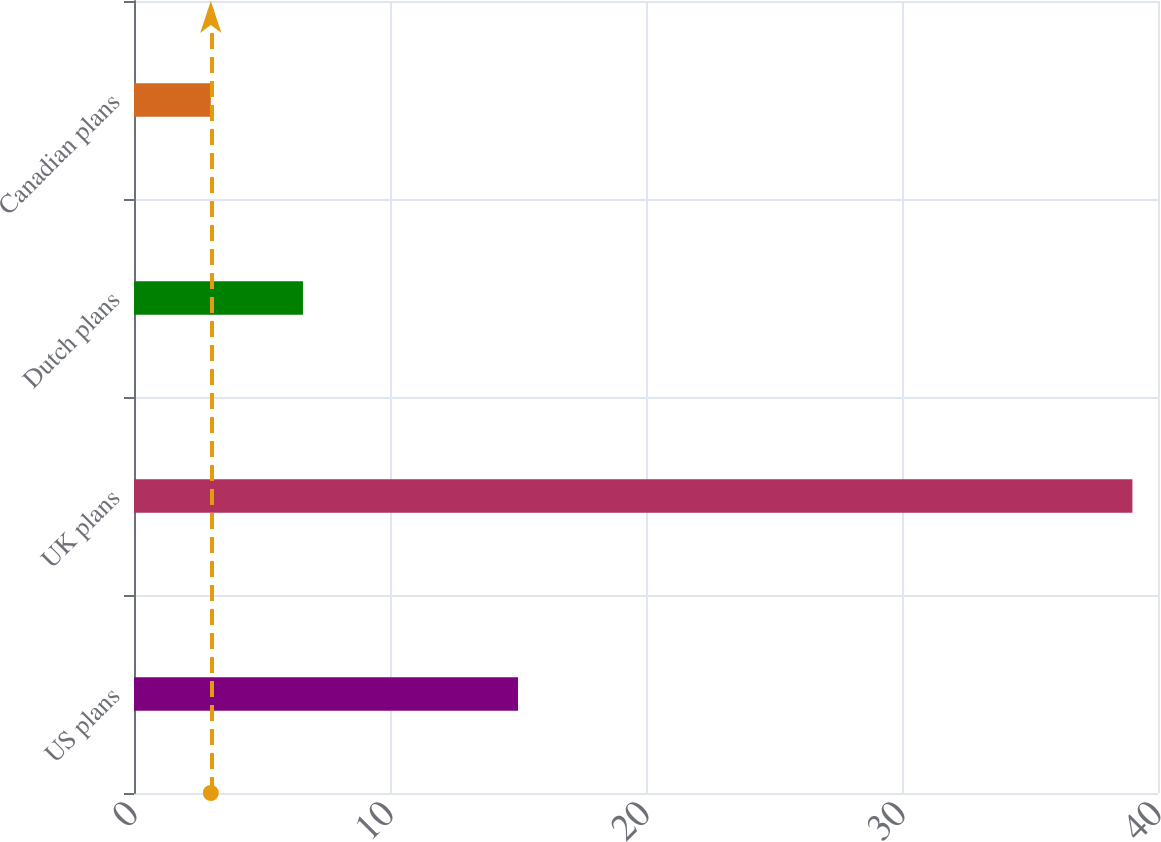<chart> <loc_0><loc_0><loc_500><loc_500><bar_chart><fcel>US plans<fcel>UK plans<fcel>Dutch plans<fcel>Canadian plans<nl><fcel>15<fcel>39<fcel>6.6<fcel>3<nl></chart> 